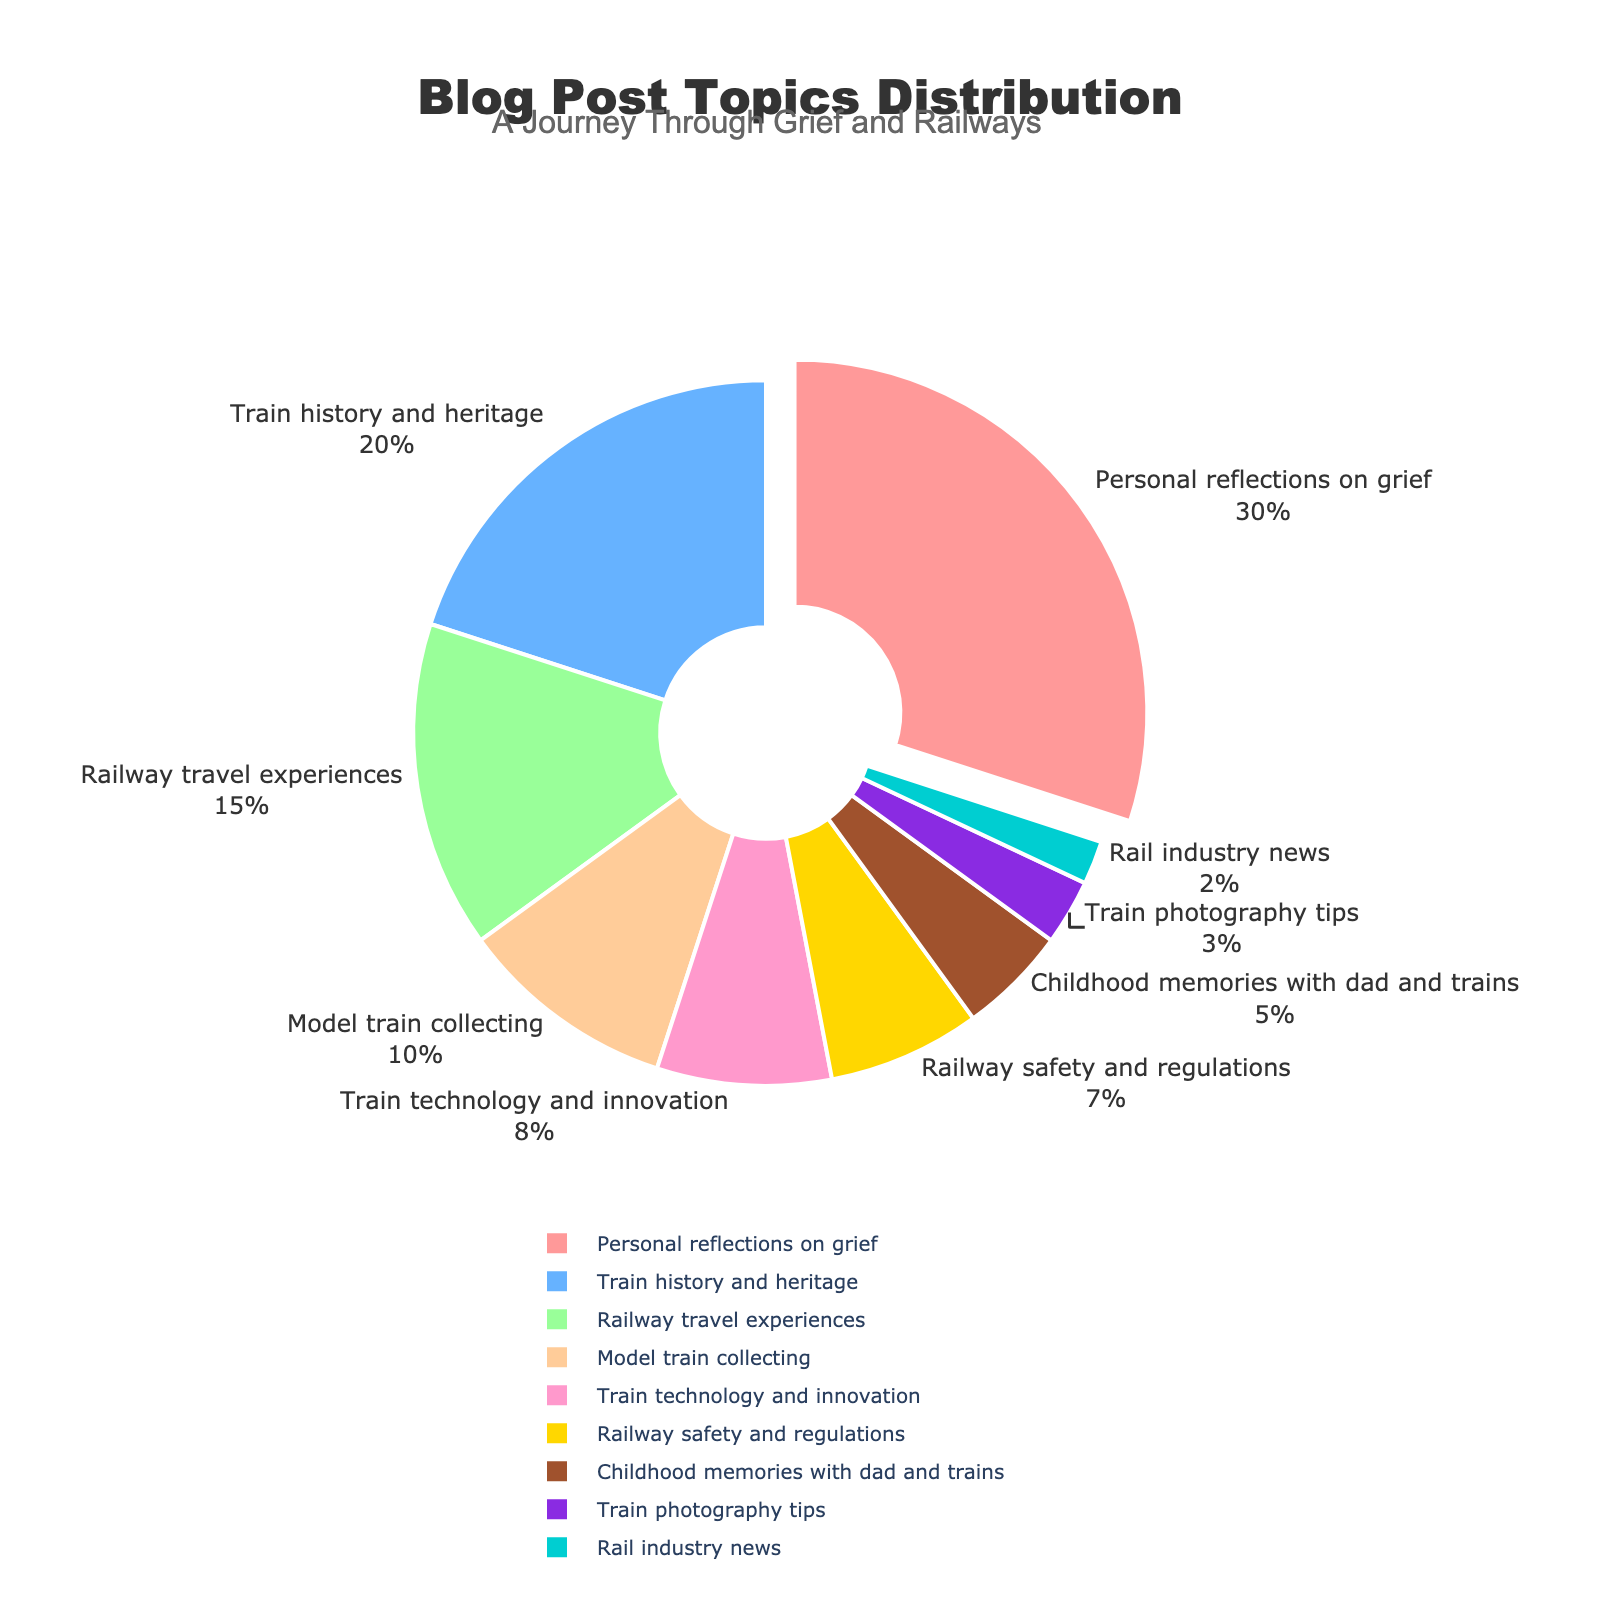What's the largest topic by percentage? The largest topic can be identified as the segment of the pie chart that is pulled out and has the largest percentage label. This is "Personal reflections on grief" with 30%.
Answer: Personal reflections on grief Which topic is covered more: "Railway safety and regulations" or "Model train collecting"? To find this, compare the percentage labels of both segments in the pie chart. "Railway safety and regulations" is 7%, while "Model train collecting" is 10%.
Answer: Model train collecting What is the combined percentage of "Train history and heritage" and "Childhood memories with dad and trains"? Sum the percentages of these two topics: 20% (Train history and heritage) + 5% (Childhood memories with dad and trains) = 25%.
Answer: 25% Which topic has the smallest share in the blog? The smallest segment in the pie chart corresponds to "Rail industry news" with 2%.
Answer: Rail industry news Compare "Train photography tips" and "Railway travel experiences": which is greater and by how much? "Railway travel experiences" has 15%, and "Train photography tips" has 3%. Calculate the difference: 15% - 3% = 12%.
Answer: Railway travel experiences by 12% What percentage of the blog posts are related to trains (excluding personal reflections on grief)? Sum the percentages of all the train-related topics: 20% + 15% + 10% + 8% + 7% + 5% + 3% + 2% = 70%.
Answer: 70% How many percentage points greater is "Train technology and innovation" compared to "Train photography tips"? "Train technology and innovation" is 8%, and "Train photography tips" is 3%. The difference is: 8% - 3% = 5%.
Answer: 5% What is the average percentage for the three smallest topics? The three smallest topics are "Rail industry news" (2%), "Train photography tips" (3%), and "Childhood memories with dad and trains" (5%). Calculate the average: (2% + 3% + 5%) / 3 = 3.33%.
Answer: 3.33% Which topic has the third highest percentage and what is its value? The third largest segment in the pie chart is "Railway travel experiences" with 15%.
Answer: Railway travel experiences, 15% By how much does the sum of "Model train collecting" and "Railway travel experiences" exceed the sum of "Railway safety and regulations" and "Train photography tips"? Calculate the sum for both pairs: 10% (Model train collecting) + 15% (Railway travel experiences) = 25%, and 7% (Railway safety and regulations) + 3% (Train photography tips) = 10%. The difference is: 25% - 10% = 15%.
Answer: 15% 